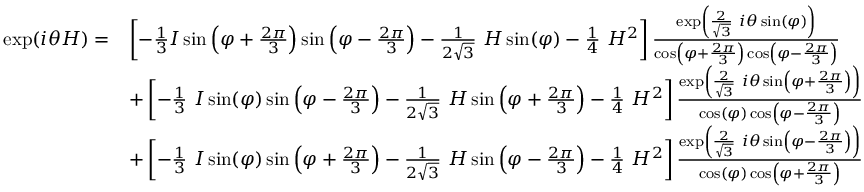Convert formula to latex. <formula><loc_0><loc_0><loc_500><loc_500>{ \begin{array} { r l } { \exp ( i \theta H ) = } & { \left [ - { \frac { 1 } { 3 } } I \sin \left ( \varphi + { \frac { 2 \pi } { 3 } } \right ) \sin \left ( \varphi - { \frac { 2 \pi } { 3 } } \right ) - { \frac { 1 } { 2 { \sqrt { 3 } } } } H \sin ( \varphi ) - { \frac { 1 } { 4 } } H ^ { 2 } \right ] { \frac { \exp \left ( { \frac { 2 } { \sqrt { 3 } } } i \theta \sin ( \varphi ) \right ) } { \cos \left ( \varphi + { \frac { 2 \pi } { 3 } } \right ) \cos \left ( \varphi - { \frac { 2 \pi } { 3 } } \right ) } } } \\ & { + \left [ - { \frac { 1 } { 3 } } I \sin ( \varphi ) \sin \left ( \varphi - { \frac { 2 \pi } { 3 } } \right ) - { \frac { 1 } { 2 { \sqrt { 3 } } } } H \sin \left ( \varphi + { \frac { 2 \pi } { 3 } } \right ) - { \frac { 1 } { 4 } } H ^ { 2 } \right ] { \frac { \exp \left ( { \frac { 2 } { \sqrt { 3 } } } i \theta \sin \left ( \varphi + { \frac { 2 \pi } { 3 } } \right ) \right ) } { \cos ( \varphi ) \cos \left ( \varphi - { \frac { 2 \pi } { 3 } } \right ) } } } \\ & { + \left [ - { \frac { 1 } { 3 } } I \sin ( \varphi ) \sin \left ( \varphi + { \frac { 2 \pi } { 3 } } \right ) - { \frac { 1 } { 2 { \sqrt { 3 } } } } H \sin \left ( \varphi - { \frac { 2 \pi } { 3 } } \right ) - { \frac { 1 } { 4 } } H ^ { 2 } \right ] { \frac { \exp \left ( { \frac { 2 } { \sqrt { 3 } } } i \theta \sin \left ( \varphi - { \frac { 2 \pi } { 3 } } \right ) \right ) } { \cos ( \varphi ) \cos \left ( \varphi + { \frac { 2 \pi } { 3 } } \right ) } } } \end{array} }</formula> 